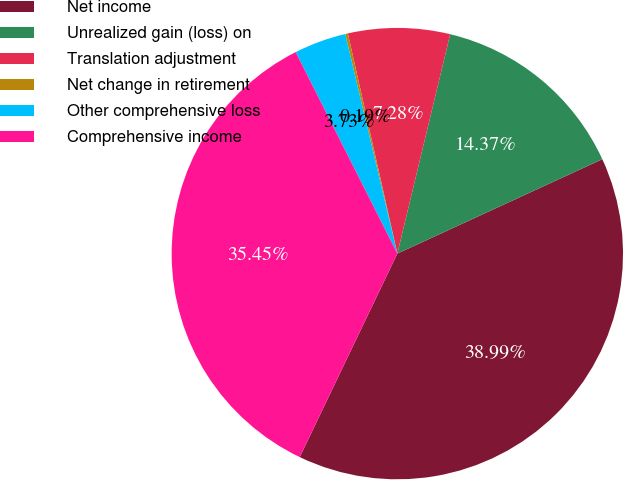<chart> <loc_0><loc_0><loc_500><loc_500><pie_chart><fcel>Net income<fcel>Unrealized gain (loss) on<fcel>Translation adjustment<fcel>Net change in retirement<fcel>Other comprehensive loss<fcel>Comprehensive income<nl><fcel>38.99%<fcel>14.37%<fcel>7.28%<fcel>0.19%<fcel>3.73%<fcel>35.45%<nl></chart> 